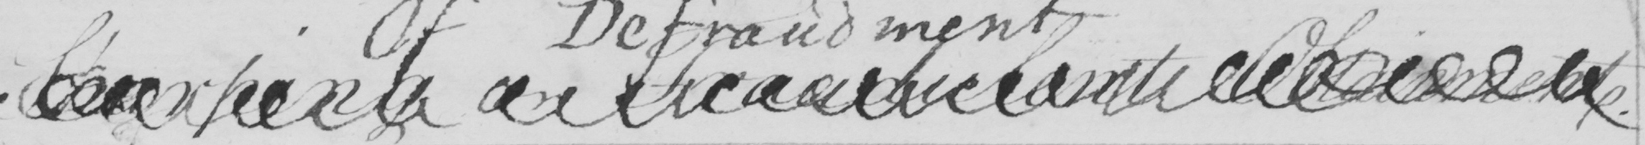Transcribe the text shown in this historical manuscript line. Sharping on Fraudulent Obtainment . 